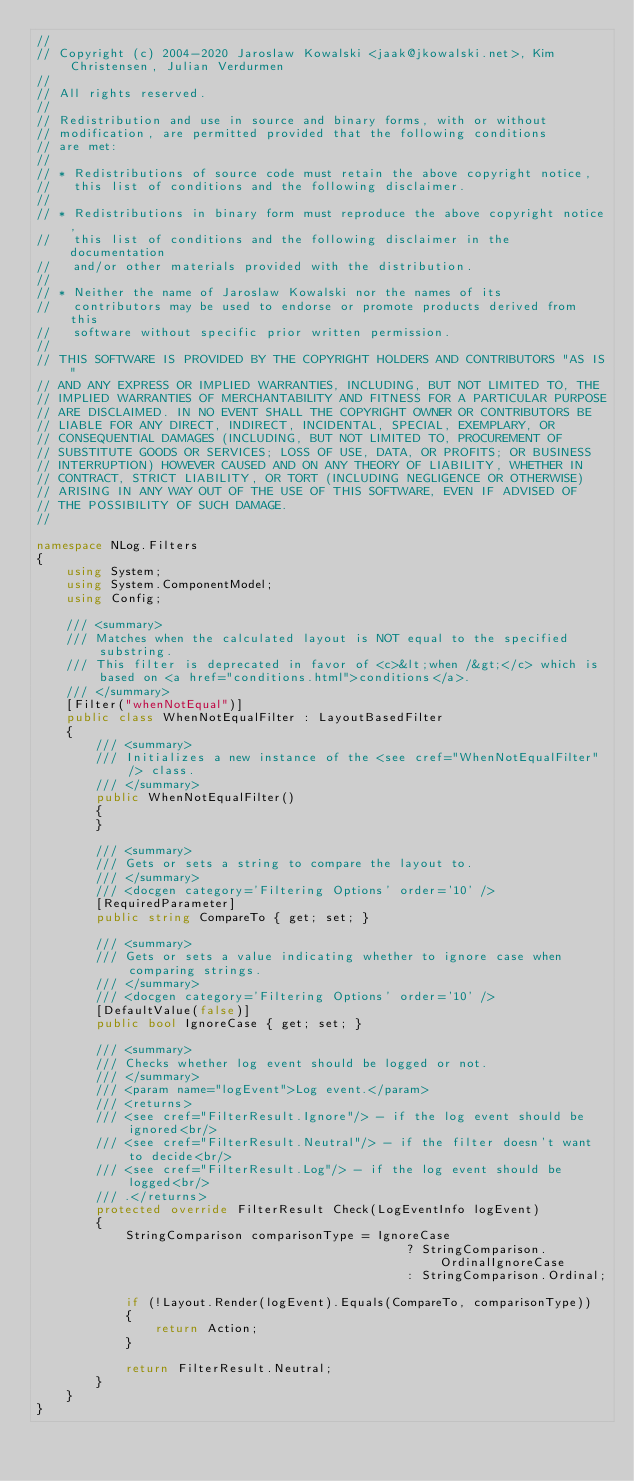Convert code to text. <code><loc_0><loc_0><loc_500><loc_500><_C#_>// 
// Copyright (c) 2004-2020 Jaroslaw Kowalski <jaak@jkowalski.net>, Kim Christensen, Julian Verdurmen
// 
// All rights reserved.
// 
// Redistribution and use in source and binary forms, with or without 
// modification, are permitted provided that the following conditions 
// are met:
// 
// * Redistributions of source code must retain the above copyright notice, 
//   this list of conditions and the following disclaimer. 
// 
// * Redistributions in binary form must reproduce the above copyright notice,
//   this list of conditions and the following disclaimer in the documentation
//   and/or other materials provided with the distribution. 
// 
// * Neither the name of Jaroslaw Kowalski nor the names of its 
//   contributors may be used to endorse or promote products derived from this
//   software without specific prior written permission. 
// 
// THIS SOFTWARE IS PROVIDED BY THE COPYRIGHT HOLDERS AND CONTRIBUTORS "AS IS"
// AND ANY EXPRESS OR IMPLIED WARRANTIES, INCLUDING, BUT NOT LIMITED TO, THE 
// IMPLIED WARRANTIES OF MERCHANTABILITY AND FITNESS FOR A PARTICULAR PURPOSE 
// ARE DISCLAIMED. IN NO EVENT SHALL THE COPYRIGHT OWNER OR CONTRIBUTORS BE 
// LIABLE FOR ANY DIRECT, INDIRECT, INCIDENTAL, SPECIAL, EXEMPLARY, OR 
// CONSEQUENTIAL DAMAGES (INCLUDING, BUT NOT LIMITED TO, PROCUREMENT OF
// SUBSTITUTE GOODS OR SERVICES; LOSS OF USE, DATA, OR PROFITS; OR BUSINESS 
// INTERRUPTION) HOWEVER CAUSED AND ON ANY THEORY OF LIABILITY, WHETHER IN 
// CONTRACT, STRICT LIABILITY, OR TORT (INCLUDING NEGLIGENCE OR OTHERWISE) 
// ARISING IN ANY WAY OUT OF THE USE OF THIS SOFTWARE, EVEN IF ADVISED OF 
// THE POSSIBILITY OF SUCH DAMAGE.
// 

namespace NLog.Filters
{
    using System;
    using System.ComponentModel;
    using Config;

    /// <summary>
    /// Matches when the calculated layout is NOT equal to the specified substring.
    /// This filter is deprecated in favor of <c>&lt;when /&gt;</c> which is based on <a href="conditions.html">conditions</a>.
    /// </summary>
    [Filter("whenNotEqual")]
    public class WhenNotEqualFilter : LayoutBasedFilter
    {
        /// <summary>
        /// Initializes a new instance of the <see cref="WhenNotEqualFilter" /> class.
        /// </summary>
        public WhenNotEqualFilter()
        {
        }

        /// <summary>
        /// Gets or sets a string to compare the layout to.
        /// </summary>
        /// <docgen category='Filtering Options' order='10' />
        [RequiredParameter]
        public string CompareTo { get; set; }

        /// <summary>
        /// Gets or sets a value indicating whether to ignore case when comparing strings.
        /// </summary>
        /// <docgen category='Filtering Options' order='10' />
        [DefaultValue(false)]
        public bool IgnoreCase { get; set; }

        /// <summary>
        /// Checks whether log event should be logged or not.
        /// </summary>
        /// <param name="logEvent">Log event.</param>
        /// <returns>
        /// <see cref="FilterResult.Ignore"/> - if the log event should be ignored<br/>
        /// <see cref="FilterResult.Neutral"/> - if the filter doesn't want to decide<br/>
        /// <see cref="FilterResult.Log"/> - if the log event should be logged<br/>
        /// .</returns>
        protected override FilterResult Check(LogEventInfo logEvent)
        {
            StringComparison comparisonType = IgnoreCase
                                                  ? StringComparison.OrdinalIgnoreCase
                                                  : StringComparison.Ordinal;

            if (!Layout.Render(logEvent).Equals(CompareTo, comparisonType))
            {
                return Action;
            }

            return FilterResult.Neutral;
        }
    }
}
</code> 